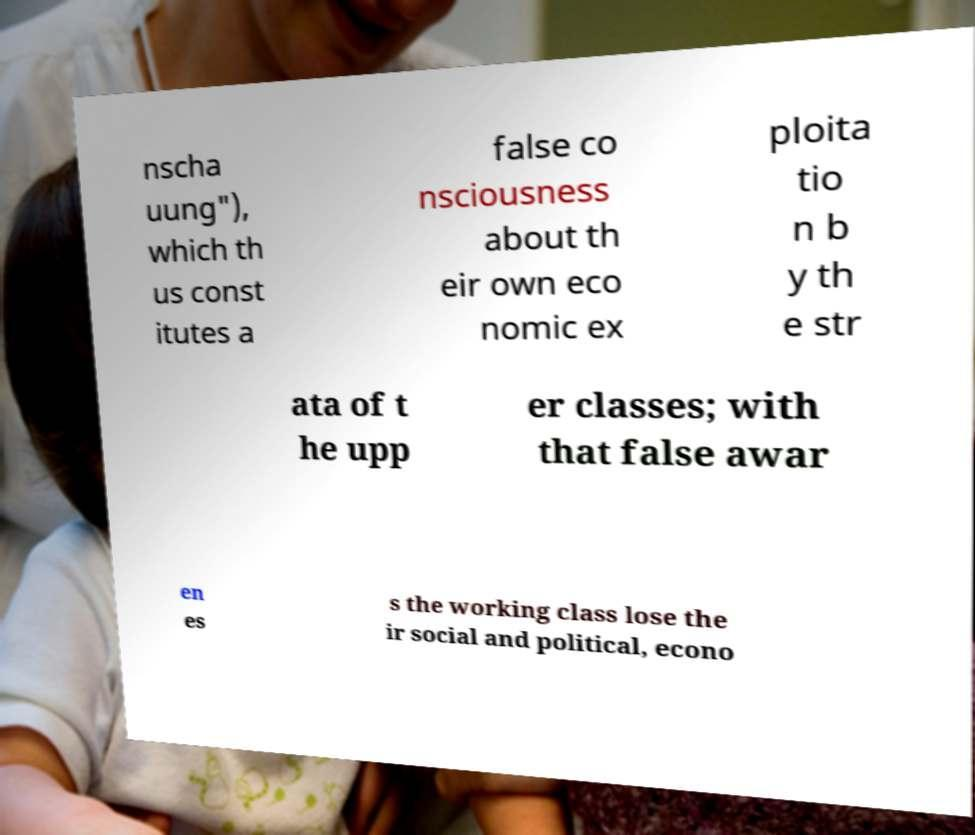Could you extract and type out the text from this image? nscha uung"), which th us const itutes a false co nsciousness about th eir own eco nomic ex ploita tio n b y th e str ata of t he upp er classes; with that false awar en es s the working class lose the ir social and political, econo 